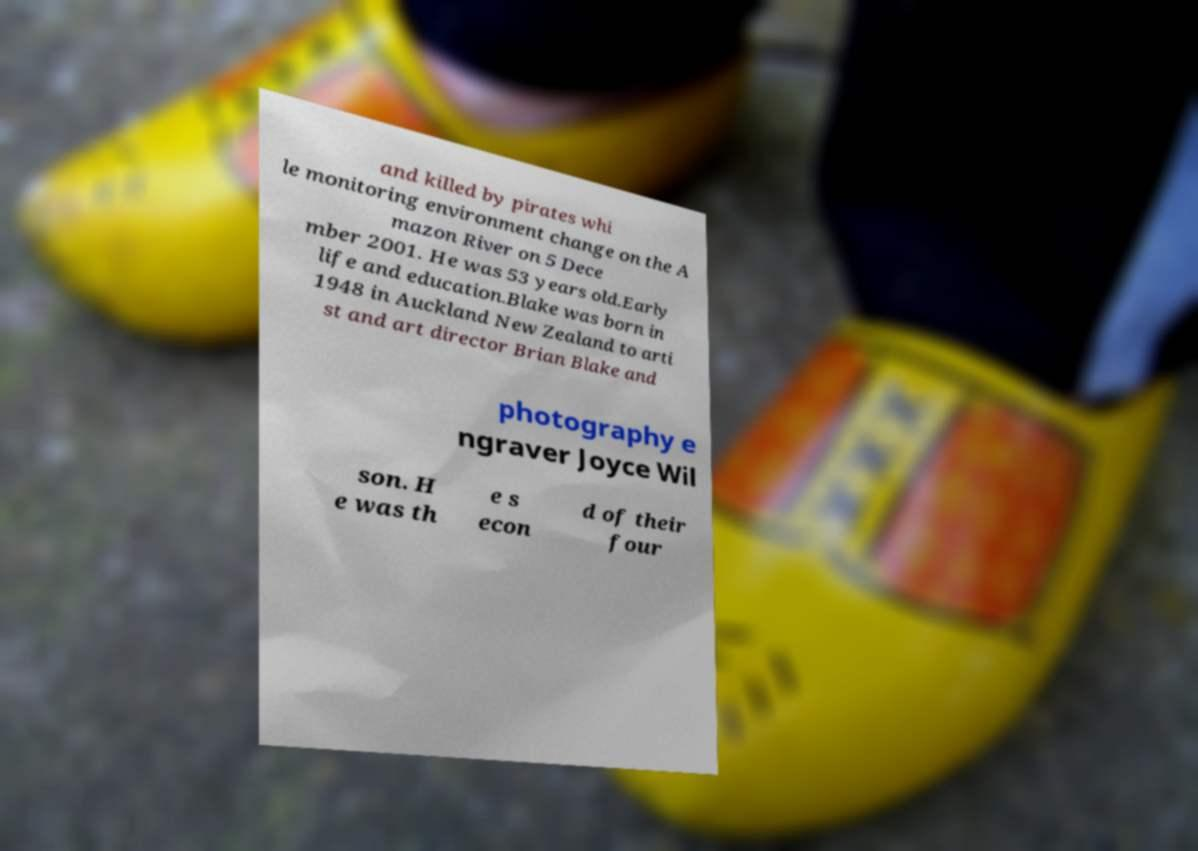Please read and relay the text visible in this image. What does it say? and killed by pirates whi le monitoring environment change on the A mazon River on 5 Dece mber 2001. He was 53 years old.Early life and education.Blake was born in 1948 in Auckland New Zealand to arti st and art director Brian Blake and photography e ngraver Joyce Wil son. H e was th e s econ d of their four 